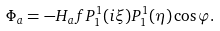Convert formula to latex. <formula><loc_0><loc_0><loc_500><loc_500>\Phi _ { a } = - H _ { a } f P ^ { 1 } _ { 1 } ( i \xi ) P ^ { 1 } _ { 1 } ( \eta ) \cos \varphi .</formula> 